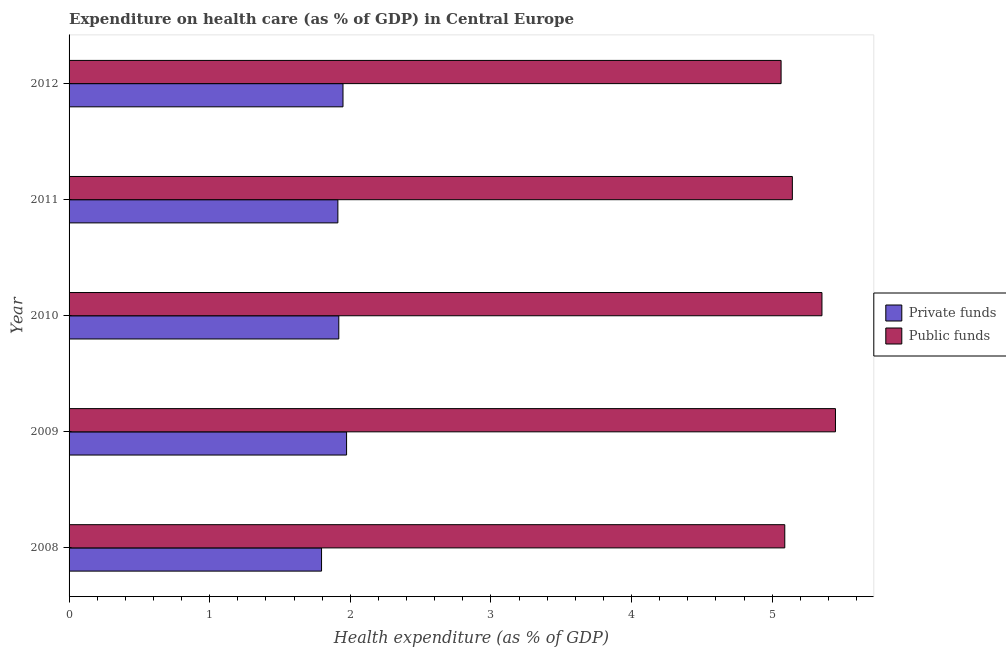How many different coloured bars are there?
Ensure brevity in your answer.  2. Are the number of bars per tick equal to the number of legend labels?
Your answer should be compact. Yes. How many bars are there on the 1st tick from the bottom?
Ensure brevity in your answer.  2. In how many cases, is the number of bars for a given year not equal to the number of legend labels?
Your answer should be very brief. 0. What is the amount of public funds spent in healthcare in 2010?
Offer a very short reply. 5.35. Across all years, what is the maximum amount of private funds spent in healthcare?
Your answer should be very brief. 1.97. Across all years, what is the minimum amount of public funds spent in healthcare?
Provide a short and direct response. 5.06. In which year was the amount of private funds spent in healthcare maximum?
Offer a terse response. 2009. In which year was the amount of private funds spent in healthcare minimum?
Keep it short and to the point. 2008. What is the total amount of private funds spent in healthcare in the graph?
Give a very brief answer. 9.55. What is the difference between the amount of private funds spent in healthcare in 2010 and that in 2011?
Your answer should be very brief. 0.01. What is the difference between the amount of public funds spent in healthcare in 2011 and the amount of private funds spent in healthcare in 2012?
Provide a succinct answer. 3.2. What is the average amount of public funds spent in healthcare per year?
Keep it short and to the point. 5.22. In the year 2012, what is the difference between the amount of private funds spent in healthcare and amount of public funds spent in healthcare?
Your answer should be compact. -3.12. In how many years, is the amount of private funds spent in healthcare greater than 5 %?
Keep it short and to the point. 0. What is the ratio of the amount of private funds spent in healthcare in 2008 to that in 2012?
Offer a very short reply. 0.92. Is the amount of public funds spent in healthcare in 2010 less than that in 2012?
Keep it short and to the point. No. What is the difference between the highest and the second highest amount of private funds spent in healthcare?
Offer a terse response. 0.03. What is the difference between the highest and the lowest amount of public funds spent in healthcare?
Provide a succinct answer. 0.39. In how many years, is the amount of private funds spent in healthcare greater than the average amount of private funds spent in healthcare taken over all years?
Offer a very short reply. 4. Is the sum of the amount of public funds spent in healthcare in 2011 and 2012 greater than the maximum amount of private funds spent in healthcare across all years?
Provide a succinct answer. Yes. What does the 1st bar from the top in 2011 represents?
Give a very brief answer. Public funds. What does the 1st bar from the bottom in 2009 represents?
Give a very brief answer. Private funds. How many bars are there?
Keep it short and to the point. 10. How many years are there in the graph?
Provide a succinct answer. 5. Are the values on the major ticks of X-axis written in scientific E-notation?
Ensure brevity in your answer.  No. Does the graph contain any zero values?
Your response must be concise. No. How many legend labels are there?
Your response must be concise. 2. How are the legend labels stacked?
Give a very brief answer. Vertical. What is the title of the graph?
Provide a succinct answer. Expenditure on health care (as % of GDP) in Central Europe. Does "Canada" appear as one of the legend labels in the graph?
Give a very brief answer. No. What is the label or title of the X-axis?
Give a very brief answer. Health expenditure (as % of GDP). What is the Health expenditure (as % of GDP) in Private funds in 2008?
Offer a terse response. 1.8. What is the Health expenditure (as % of GDP) in Public funds in 2008?
Give a very brief answer. 5.09. What is the Health expenditure (as % of GDP) of Private funds in 2009?
Your answer should be compact. 1.97. What is the Health expenditure (as % of GDP) of Public funds in 2009?
Provide a short and direct response. 5.45. What is the Health expenditure (as % of GDP) in Private funds in 2010?
Provide a succinct answer. 1.92. What is the Health expenditure (as % of GDP) in Public funds in 2010?
Give a very brief answer. 5.35. What is the Health expenditure (as % of GDP) of Private funds in 2011?
Keep it short and to the point. 1.91. What is the Health expenditure (as % of GDP) in Public funds in 2011?
Give a very brief answer. 5.14. What is the Health expenditure (as % of GDP) in Private funds in 2012?
Your response must be concise. 1.95. What is the Health expenditure (as % of GDP) in Public funds in 2012?
Ensure brevity in your answer.  5.06. Across all years, what is the maximum Health expenditure (as % of GDP) in Private funds?
Ensure brevity in your answer.  1.97. Across all years, what is the maximum Health expenditure (as % of GDP) of Public funds?
Ensure brevity in your answer.  5.45. Across all years, what is the minimum Health expenditure (as % of GDP) in Private funds?
Offer a very short reply. 1.8. Across all years, what is the minimum Health expenditure (as % of GDP) of Public funds?
Provide a short and direct response. 5.06. What is the total Health expenditure (as % of GDP) of Private funds in the graph?
Offer a terse response. 9.55. What is the total Health expenditure (as % of GDP) of Public funds in the graph?
Offer a very short reply. 26.1. What is the difference between the Health expenditure (as % of GDP) in Private funds in 2008 and that in 2009?
Keep it short and to the point. -0.18. What is the difference between the Health expenditure (as % of GDP) of Public funds in 2008 and that in 2009?
Provide a succinct answer. -0.36. What is the difference between the Health expenditure (as % of GDP) of Private funds in 2008 and that in 2010?
Provide a succinct answer. -0.12. What is the difference between the Health expenditure (as % of GDP) in Public funds in 2008 and that in 2010?
Give a very brief answer. -0.26. What is the difference between the Health expenditure (as % of GDP) of Private funds in 2008 and that in 2011?
Make the answer very short. -0.12. What is the difference between the Health expenditure (as % of GDP) in Public funds in 2008 and that in 2011?
Your answer should be compact. -0.05. What is the difference between the Health expenditure (as % of GDP) of Private funds in 2008 and that in 2012?
Your answer should be compact. -0.15. What is the difference between the Health expenditure (as % of GDP) in Public funds in 2008 and that in 2012?
Offer a very short reply. 0.03. What is the difference between the Health expenditure (as % of GDP) of Private funds in 2009 and that in 2010?
Give a very brief answer. 0.06. What is the difference between the Health expenditure (as % of GDP) in Public funds in 2009 and that in 2010?
Provide a succinct answer. 0.1. What is the difference between the Health expenditure (as % of GDP) of Private funds in 2009 and that in 2011?
Provide a short and direct response. 0.06. What is the difference between the Health expenditure (as % of GDP) in Public funds in 2009 and that in 2011?
Keep it short and to the point. 0.31. What is the difference between the Health expenditure (as % of GDP) in Private funds in 2009 and that in 2012?
Give a very brief answer. 0.03. What is the difference between the Health expenditure (as % of GDP) in Public funds in 2009 and that in 2012?
Provide a succinct answer. 0.39. What is the difference between the Health expenditure (as % of GDP) in Private funds in 2010 and that in 2011?
Your response must be concise. 0.01. What is the difference between the Health expenditure (as % of GDP) in Public funds in 2010 and that in 2011?
Offer a very short reply. 0.21. What is the difference between the Health expenditure (as % of GDP) of Private funds in 2010 and that in 2012?
Provide a succinct answer. -0.03. What is the difference between the Health expenditure (as % of GDP) in Public funds in 2010 and that in 2012?
Your answer should be compact. 0.29. What is the difference between the Health expenditure (as % of GDP) in Private funds in 2011 and that in 2012?
Your response must be concise. -0.04. What is the difference between the Health expenditure (as % of GDP) of Public funds in 2011 and that in 2012?
Ensure brevity in your answer.  0.08. What is the difference between the Health expenditure (as % of GDP) of Private funds in 2008 and the Health expenditure (as % of GDP) of Public funds in 2009?
Your answer should be compact. -3.65. What is the difference between the Health expenditure (as % of GDP) of Private funds in 2008 and the Health expenditure (as % of GDP) of Public funds in 2010?
Your response must be concise. -3.56. What is the difference between the Health expenditure (as % of GDP) of Private funds in 2008 and the Health expenditure (as % of GDP) of Public funds in 2011?
Provide a succinct answer. -3.35. What is the difference between the Health expenditure (as % of GDP) in Private funds in 2008 and the Health expenditure (as % of GDP) in Public funds in 2012?
Offer a terse response. -3.27. What is the difference between the Health expenditure (as % of GDP) of Private funds in 2009 and the Health expenditure (as % of GDP) of Public funds in 2010?
Provide a succinct answer. -3.38. What is the difference between the Health expenditure (as % of GDP) of Private funds in 2009 and the Health expenditure (as % of GDP) of Public funds in 2011?
Make the answer very short. -3.17. What is the difference between the Health expenditure (as % of GDP) of Private funds in 2009 and the Health expenditure (as % of GDP) of Public funds in 2012?
Provide a succinct answer. -3.09. What is the difference between the Health expenditure (as % of GDP) of Private funds in 2010 and the Health expenditure (as % of GDP) of Public funds in 2011?
Give a very brief answer. -3.23. What is the difference between the Health expenditure (as % of GDP) of Private funds in 2010 and the Health expenditure (as % of GDP) of Public funds in 2012?
Give a very brief answer. -3.15. What is the difference between the Health expenditure (as % of GDP) in Private funds in 2011 and the Health expenditure (as % of GDP) in Public funds in 2012?
Provide a succinct answer. -3.15. What is the average Health expenditure (as % of GDP) of Private funds per year?
Make the answer very short. 1.91. What is the average Health expenditure (as % of GDP) in Public funds per year?
Offer a very short reply. 5.22. In the year 2008, what is the difference between the Health expenditure (as % of GDP) of Private funds and Health expenditure (as % of GDP) of Public funds?
Offer a terse response. -3.29. In the year 2009, what is the difference between the Health expenditure (as % of GDP) in Private funds and Health expenditure (as % of GDP) in Public funds?
Provide a succinct answer. -3.48. In the year 2010, what is the difference between the Health expenditure (as % of GDP) of Private funds and Health expenditure (as % of GDP) of Public funds?
Provide a succinct answer. -3.44. In the year 2011, what is the difference between the Health expenditure (as % of GDP) in Private funds and Health expenditure (as % of GDP) in Public funds?
Offer a terse response. -3.23. In the year 2012, what is the difference between the Health expenditure (as % of GDP) of Private funds and Health expenditure (as % of GDP) of Public funds?
Provide a succinct answer. -3.12. What is the ratio of the Health expenditure (as % of GDP) in Private funds in 2008 to that in 2009?
Make the answer very short. 0.91. What is the ratio of the Health expenditure (as % of GDP) of Public funds in 2008 to that in 2009?
Provide a short and direct response. 0.93. What is the ratio of the Health expenditure (as % of GDP) in Private funds in 2008 to that in 2010?
Ensure brevity in your answer.  0.94. What is the ratio of the Health expenditure (as % of GDP) of Public funds in 2008 to that in 2010?
Make the answer very short. 0.95. What is the ratio of the Health expenditure (as % of GDP) of Private funds in 2008 to that in 2011?
Make the answer very short. 0.94. What is the ratio of the Health expenditure (as % of GDP) of Public funds in 2008 to that in 2011?
Offer a very short reply. 0.99. What is the ratio of the Health expenditure (as % of GDP) of Private funds in 2008 to that in 2012?
Provide a succinct answer. 0.92. What is the ratio of the Health expenditure (as % of GDP) in Public funds in 2008 to that in 2012?
Provide a short and direct response. 1.01. What is the ratio of the Health expenditure (as % of GDP) of Private funds in 2009 to that in 2010?
Offer a very short reply. 1.03. What is the ratio of the Health expenditure (as % of GDP) of Public funds in 2009 to that in 2010?
Your answer should be compact. 1.02. What is the ratio of the Health expenditure (as % of GDP) of Private funds in 2009 to that in 2011?
Your answer should be compact. 1.03. What is the ratio of the Health expenditure (as % of GDP) in Public funds in 2009 to that in 2011?
Make the answer very short. 1.06. What is the ratio of the Health expenditure (as % of GDP) in Private funds in 2009 to that in 2012?
Your answer should be very brief. 1.01. What is the ratio of the Health expenditure (as % of GDP) in Public funds in 2009 to that in 2012?
Your answer should be very brief. 1.08. What is the ratio of the Health expenditure (as % of GDP) of Public funds in 2010 to that in 2011?
Your response must be concise. 1.04. What is the ratio of the Health expenditure (as % of GDP) of Private funds in 2010 to that in 2012?
Keep it short and to the point. 0.98. What is the ratio of the Health expenditure (as % of GDP) of Public funds in 2010 to that in 2012?
Offer a very short reply. 1.06. What is the ratio of the Health expenditure (as % of GDP) in Private funds in 2011 to that in 2012?
Ensure brevity in your answer.  0.98. What is the ratio of the Health expenditure (as % of GDP) in Public funds in 2011 to that in 2012?
Your answer should be very brief. 1.02. What is the difference between the highest and the second highest Health expenditure (as % of GDP) of Private funds?
Your answer should be very brief. 0.03. What is the difference between the highest and the second highest Health expenditure (as % of GDP) in Public funds?
Your answer should be compact. 0.1. What is the difference between the highest and the lowest Health expenditure (as % of GDP) of Private funds?
Keep it short and to the point. 0.18. What is the difference between the highest and the lowest Health expenditure (as % of GDP) in Public funds?
Ensure brevity in your answer.  0.39. 